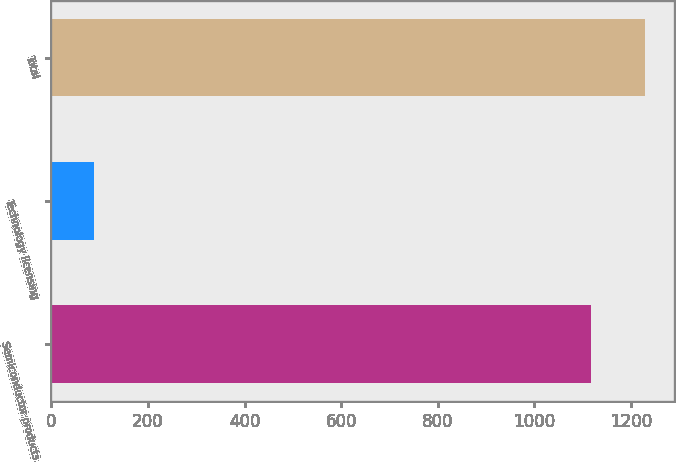Convert chart to OTSL. <chart><loc_0><loc_0><loc_500><loc_500><bar_chart><fcel>Semiconductor products<fcel>Technology licensing<fcel>Total<nl><fcel>1116.4<fcel>89.1<fcel>1228.04<nl></chart> 